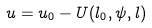<formula> <loc_0><loc_0><loc_500><loc_500>u = u _ { 0 } - U ( l _ { 0 } , \psi , l )</formula> 